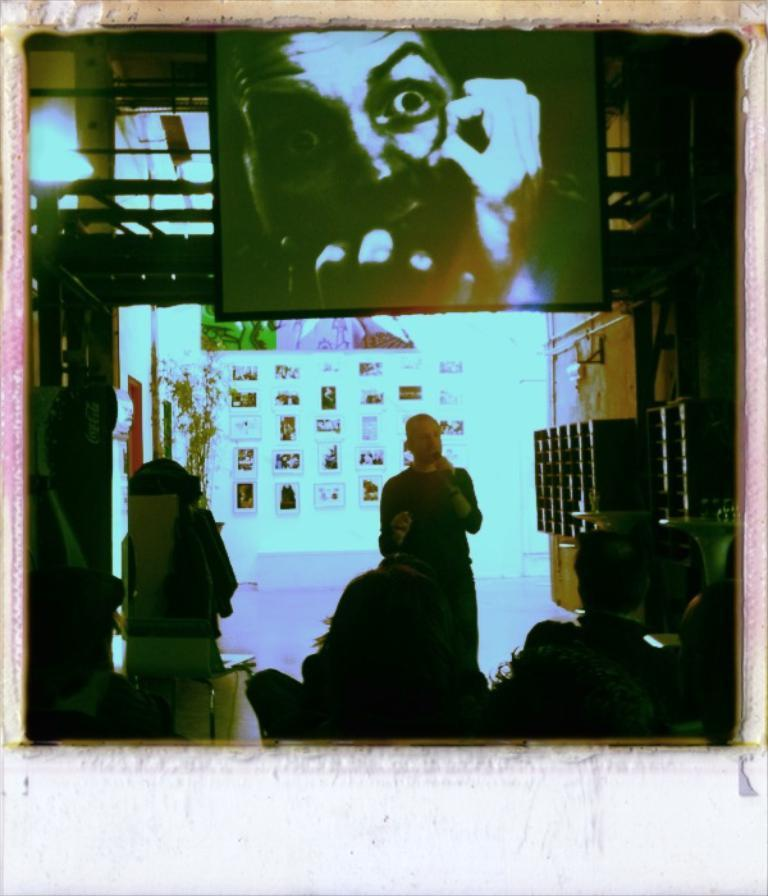What type of structure can be seen in the image? There is a wall in the image. What is hanging on the wall? There are photo frames in the image. What type of device is visible in the image? There is a screen in the image. Are there any people in the image? Yes, there are people present in the image. What type of badge can be seen on the people in the image? There is no badge visible on the people in the image. What type of ink is used to write on the wall in the image? There is no writing on the wall in the image, so it is not possible to determine the type of ink used. 